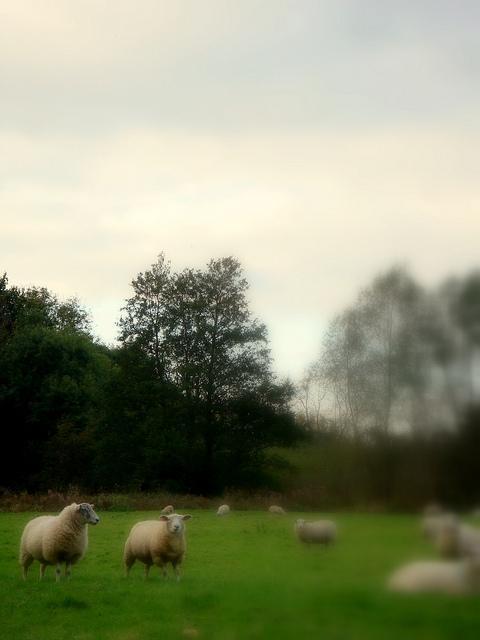What is the condition of the sky?
Make your selection from the four choices given to correctly answer the question.
Options: Clear skies, overcast, mostly sunny, mostly cloudy. Overcast. 